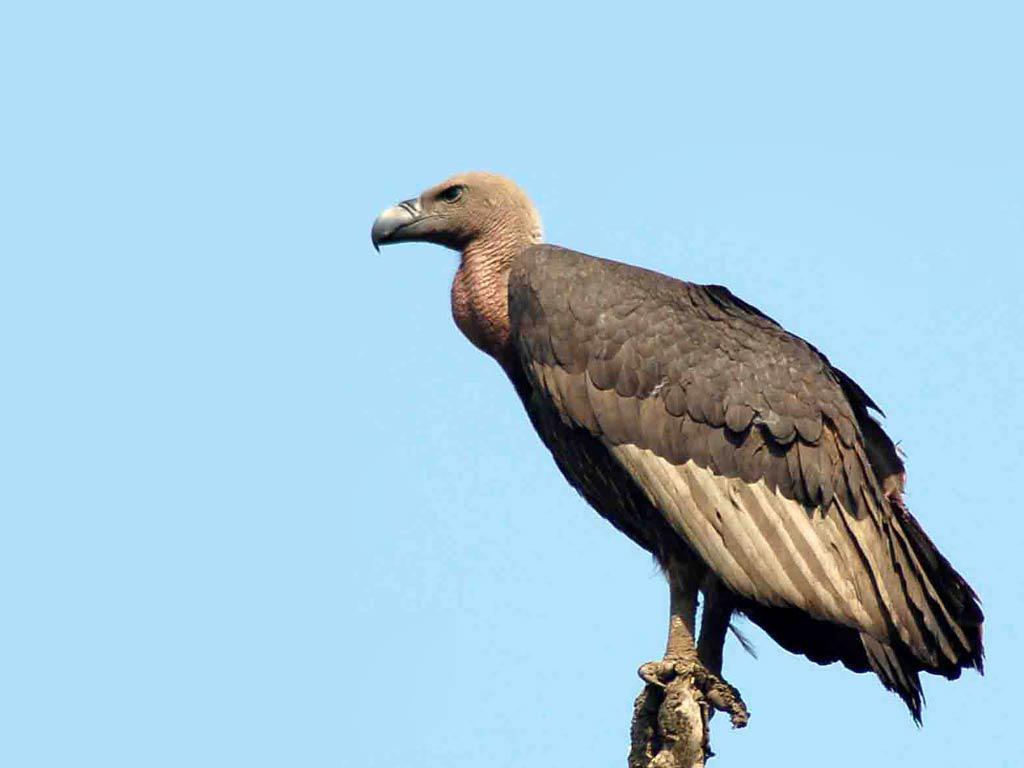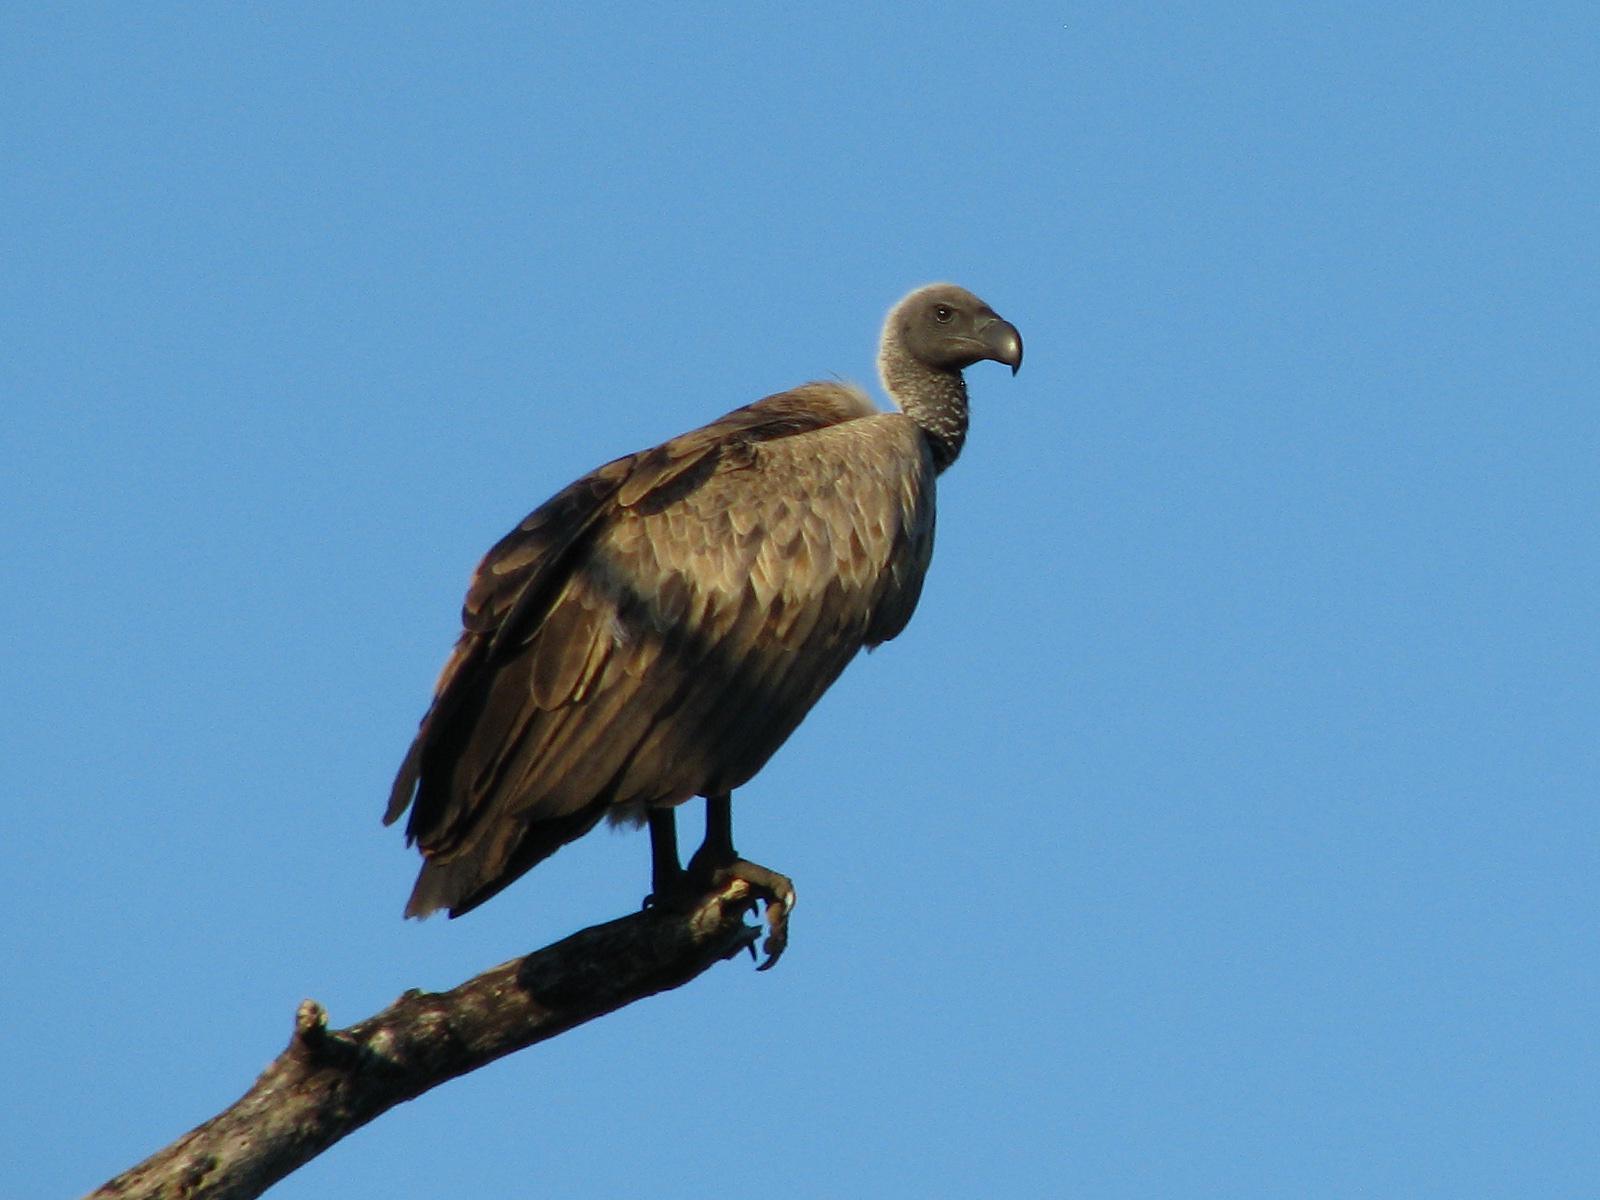The first image is the image on the left, the second image is the image on the right. Examine the images to the left and right. Is the description "Two vultures are facing the opposite of each other." accurate? Answer yes or no. Yes. 